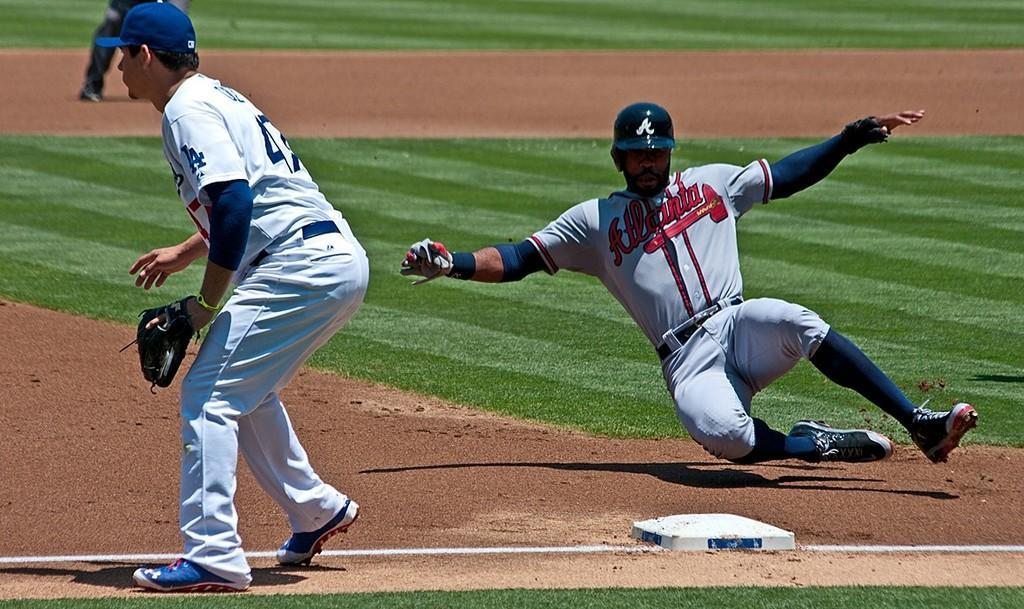How would you summarize this image in a sentence or two? In this image we can see two persons, one of them is falling down, they are playing baseball, at the background we can see the legs of a person. 